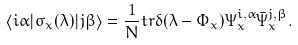<formula> <loc_0><loc_0><loc_500><loc_500>\left \langle i \alpha | \sigma _ { x } ( \lambda ) | j \beta \right \rangle = \frac { 1 } { N } t r \delta ( \lambda - \Phi _ { x } ) \Psi _ { x } ^ { i , \alpha } \bar { \Psi } _ { x } ^ { j , \beta } .</formula> 